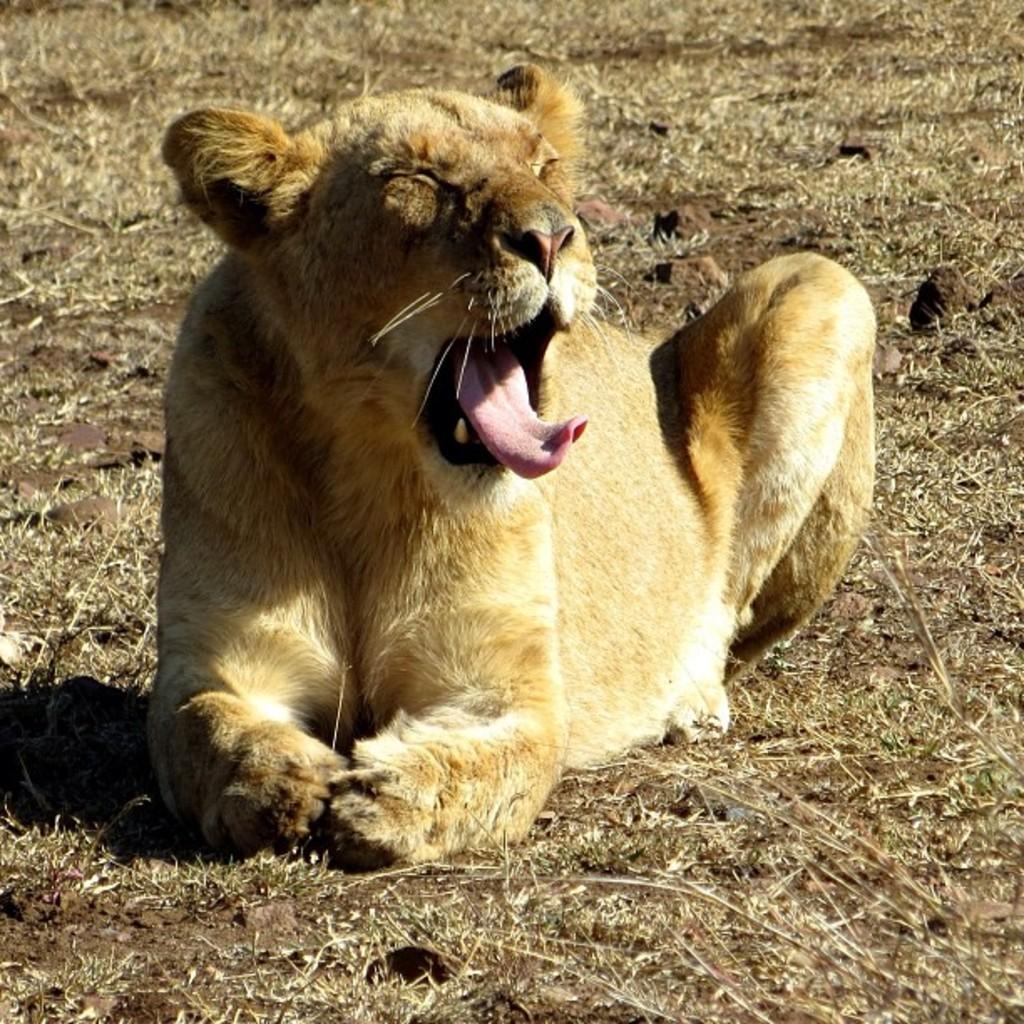How would you summarize this image in a sentence or two? In the image we can see there is a lioness sitting on the ground and the ground is covered with grass. 